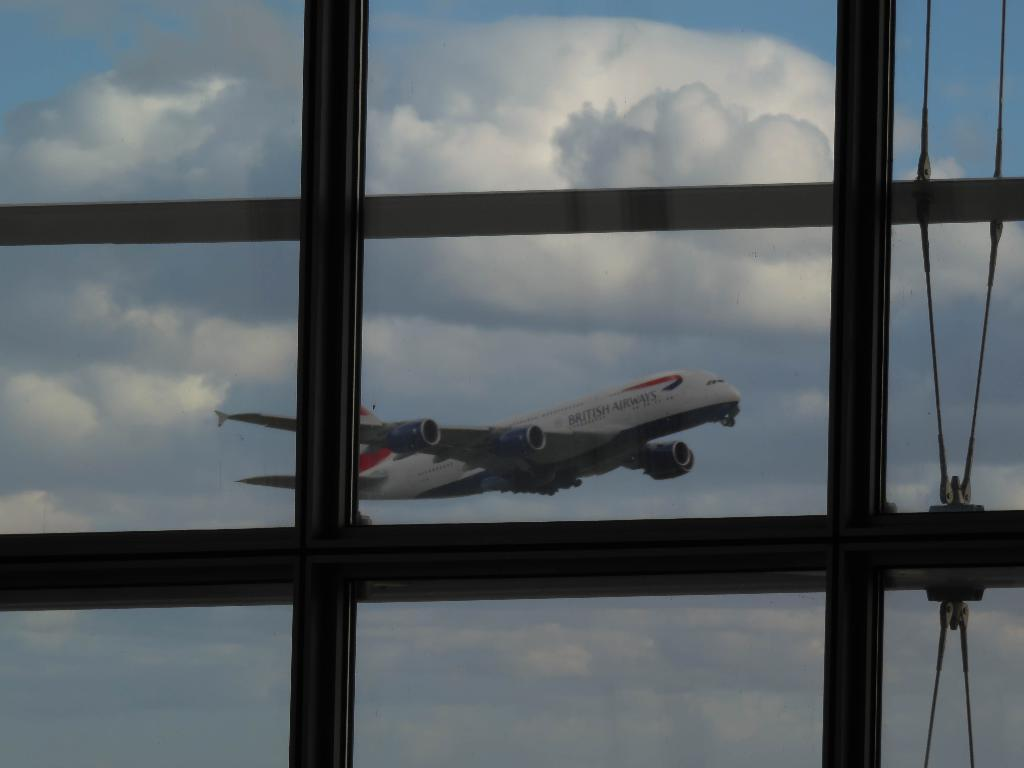What type of structure can be seen in the image? There is a glass window in the image. What can be found on the right side of the image? There are ropes on the right side of the image. What is visible through the glass window? A flight is visible through the glass window. What is visible in the background of the image? There is sky visible in the background of the image. What can be observed in the sky? Clouds are present in the sky. What type of mountain can be seen in the image? There is no mountain present in the image. 